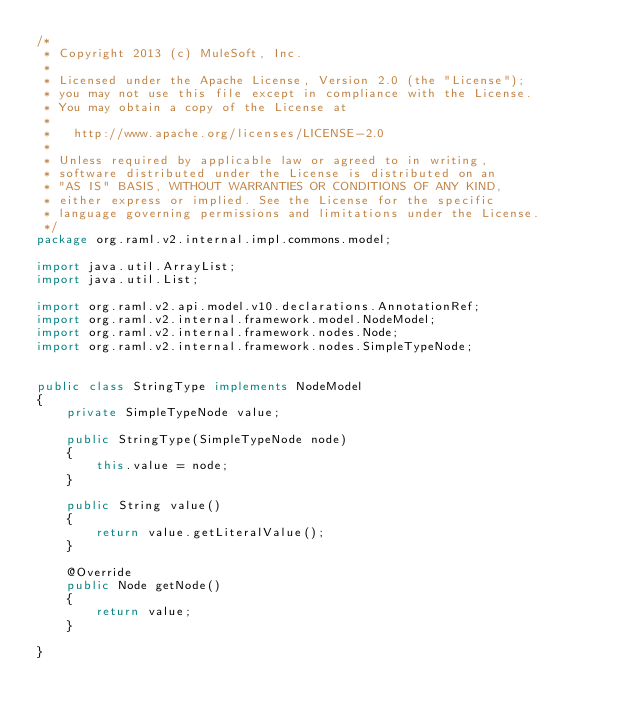Convert code to text. <code><loc_0><loc_0><loc_500><loc_500><_Java_>/*
 * Copyright 2013 (c) MuleSoft, Inc.
 *
 * Licensed under the Apache License, Version 2.0 (the "License");
 * you may not use this file except in compliance with the License.
 * You may obtain a copy of the License at
 *
 *   http://www.apache.org/licenses/LICENSE-2.0
 *
 * Unless required by applicable law or agreed to in writing,
 * software distributed under the License is distributed on an
 * "AS IS" BASIS, WITHOUT WARRANTIES OR CONDITIONS OF ANY KIND,
 * either express or implied. See the License for the specific
 * language governing permissions and limitations under the License.
 */
package org.raml.v2.internal.impl.commons.model;

import java.util.ArrayList;
import java.util.List;

import org.raml.v2.api.model.v10.declarations.AnnotationRef;
import org.raml.v2.internal.framework.model.NodeModel;
import org.raml.v2.internal.framework.nodes.Node;
import org.raml.v2.internal.framework.nodes.SimpleTypeNode;


public class StringType implements NodeModel
{
    private SimpleTypeNode value;

    public StringType(SimpleTypeNode node)
    {
        this.value = node;
    }

    public String value()
    {
        return value.getLiteralValue();
    }

    @Override
    public Node getNode()
    {
        return value;
    }

}
</code> 